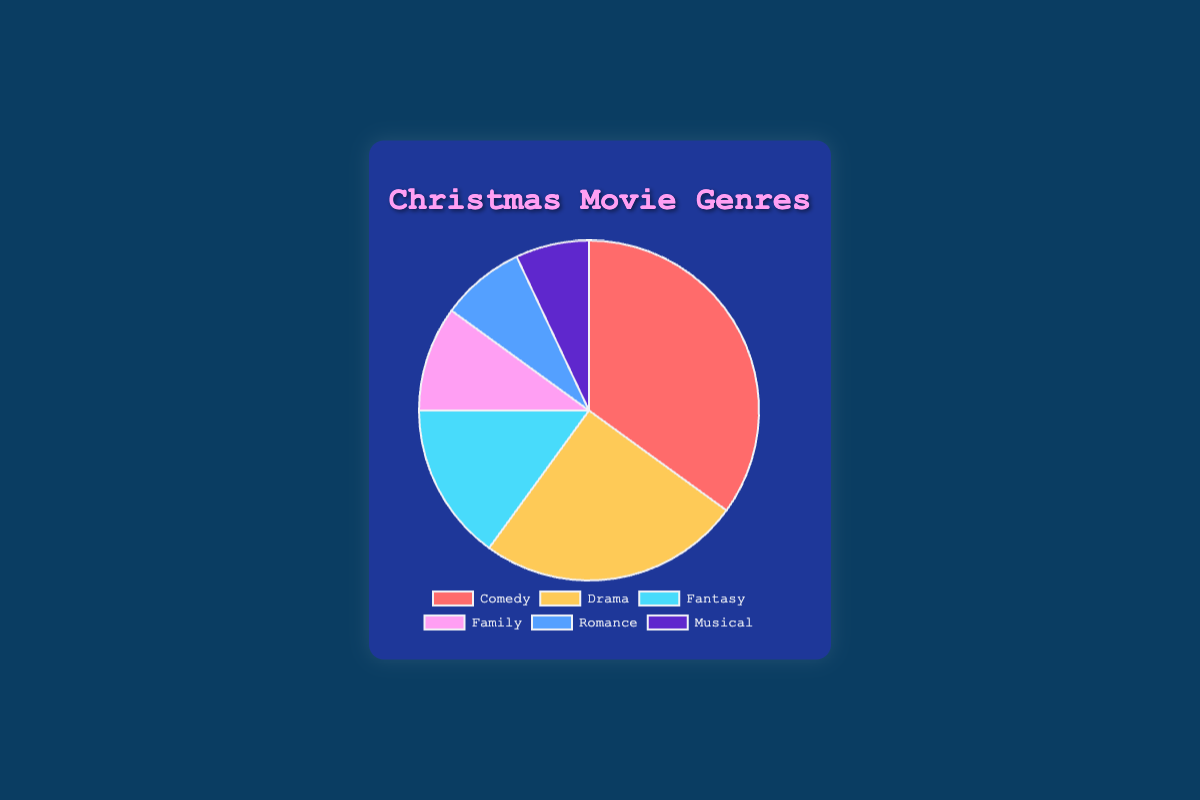What percentage of movies are Comedy and Drama combined? First, identify the percentages for Comedy (35%) and Drama (25%). Add these two percentages together: 35 + 25 = 60.
Answer: 60% Which genre has a higher share, Fantasy or Family? Look at the percentages for Fantasy (15%) and Family (10%). Compare the two: 15 is greater than 10.
Answer: Fantasy How much larger is the Comedy genre compared to the Romance genre? Determine the percentages for Comedy (35%) and Romance (8%). Subtract the percentage for Romance from Comedy: 35 - 8 = 27.
Answer: 27% What is the total percentage of genres that are not Family or Musical? First, find the percentages for Family (10%) and Musical (7%). Add these together: 10 + 7 = 17. Then subtract this from the total percentage: 100 - 17 = 83.
Answer: 83% Which genre occupies the smallest percentage and what is its value? Identify the genre with the smallest percentage, which is Musical, at 7%.
Answer: Musical, 7% Compare the percentages of Fantasy and Romance together versus Comedy. Are they less than, equal to, or greater than Comedy? First, add the percentages for Fantasy (15%) and Romance (8%): 15 + 8 = 23%. Compare this to Comedy's percentage (35%). 23% is less than 35%.
Answer: Less than What is the difference in percentages between the two genres with the largest and smallest shares? The genre with the largest share is Comedy (35%) and the smallest share is Musical (7%). Find the difference: 35 - 7 = 28.
Answer: 28% What is the combined percentage of Drama, Romance, and Musical? Identify the percentages for Drama (25%), Romance (8%), and Musical (7%). Add these together: 25 + 8 + 7 = 40.
Answer: 40% Which genre is represented by the light blue color in the chart? The chart shows Family in light blue. Check the legend for color coding.
Answer: Family If you combine the Family and Romance genres, do they add up to more or less than the Drama genre? First, add the percentages for Family (10%) and Romance (8%): 10 + 8 = 18. Compare this to Drama's percentage (25%). 18 is less than 25.
Answer: Less than 